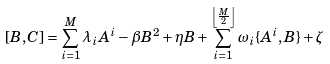<formula> <loc_0><loc_0><loc_500><loc_500>[ B , C ] = \sum _ { i = 1 } ^ { M } \lambda _ { i } A ^ { i } - \beta B ^ { 2 } + \eta B + \sum _ { i = 1 } ^ { \left \lfloor \frac { M } { 2 } \right \rfloor } \omega _ { i } \{ A ^ { i } , B \} + \zeta</formula> 